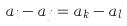Convert formula to latex. <formula><loc_0><loc_0><loc_500><loc_500>a _ { i } - a _ { j } = a _ { k } - a _ { l }</formula> 